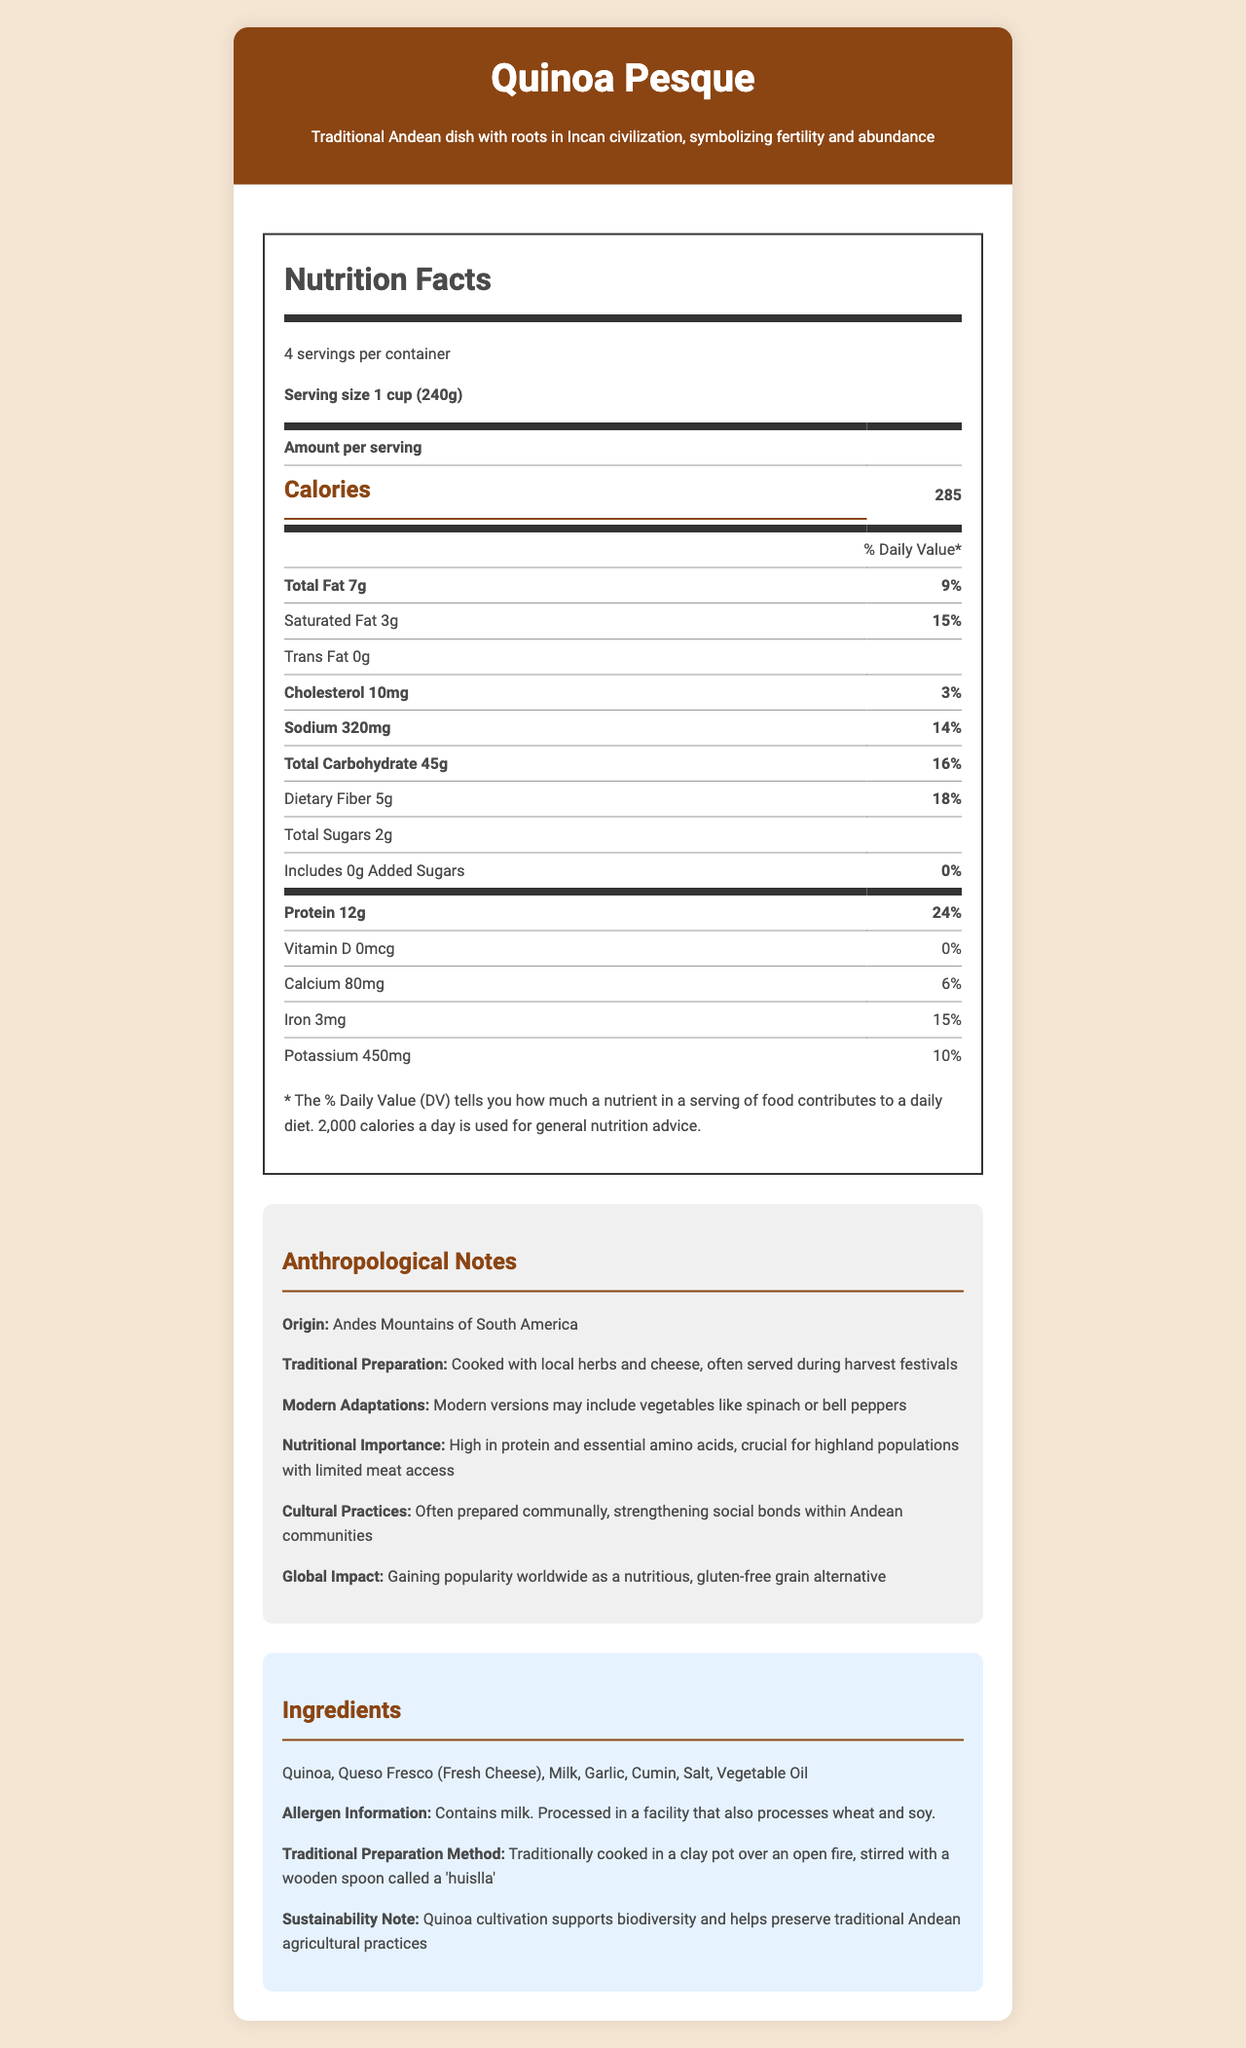How many servings are in one container of Quinoa Pesque? The document states that there are 4 servings per container for Quinoa Pesque.
Answer: 4 servings What is the serving size of Quinoa Pesque? The serving size of Quinoa Pesque is listed as 1 cup (240g) in the document.
Answer: 1 cup (240g) How many calories are there per serving? The number of calories per serving of Quinoa Pesque is 285, as mentioned in the document.
Answer: 285 calories What percentage of daily value for protein does one serving of Quinoa Pesque provide? One serving of Quinoa Pesque provides 24% of the daily value for protein.
Answer: 24% What is the origin of Quinoa Pesque? The document states that the origin of Quinoa Pesque is the Andes Mountains of South America.
Answer: Andes Mountains of South America How much saturated fat is in one serving? One serving of Quinoa Pesque contains 3 grams of saturated fat, as mentioned in the document.
Answer: 3g Does Quinoa Pesque contain any added sugars? The document states that Quinoa Pesque contains 0 grams of added sugars.
Answer: No What is the traditional preparation method of Quinoa Pesque? The traditional preparation method listed in the document describes cooking in a clay pot over an open fire, stirred with a wooden spoon called a 'huislla'.
Answer: Cooked in a clay pot over an open fire, stirred with a wooden spoon called a 'huislla' Which of the following ingredients are NOT included in Quinoa Pesque? A. Quinoa B. Queso Fresco (Fresh Cheese) C. Chicken D. Garlic Chicken is not listed among the ingredients in the document, whereas Quinoa, Queso Fresco, and Garlic are included.
Answer: C. Chicken What makes Quinoa Pesque culturally significant? A. It is a staple food worldwide B. It has roots in Incan civilization and symbolizes fertility and abundance C. It was created in the 20th century D. It is a common fast food item The document states that Quinoa Pesque's cultural significance is due to its roots in Incan civilization and its symbolism of fertility and abundance.
Answer: B. It has roots in Incan civilization and symbolizes fertility and abundance Is Quinoa Pesque considered a sustainable food option? The document mentions that quinoa cultivation supports biodiversity and helps preserve traditional Andean agricultural practices, making it a sustainable food option.
Answer: Yes Summarize the main cultural and nutritional highlights of Quinoa Pesque. The document extensively covers the cultural significance of Quinoa Pesque, its traditional and modern preparations, nutritional importance, cultural practices, and its global impact, summarizing how it is both culturally significant and nutritionally beneficial.
Answer: Quinoa Pesque is a traditional Andean dish with roots in the Incan civilization, symbolizing fertility and abundance. It has a high protein content, essential amino acids, and is low in added sugars. Traditionally prepared in a communal setting, it strengthens social bonds within Andean communities. Modern adaptations include adding vegetables like spinach or bell peppers. The dish supports sustainability and has gained popularity worldwide as a nutritious, gluten-free grain alternative. What are the allergens noted in Quinoa Pesque? The document notes that Quinoa Pesque contains milk and is processed in a facility that also processes wheat and soy.
Answer: Milk What are the health benefits of consuming Quinoa Pesque for highland populations? The document states that Quinoa Pesque is high in protein and essential amino acids, which are crucial for highland populations with limited access to meat.
Answer: High in protein and essential amino acids, crucial for populations with limited meat access What percentage of the daily value of calcium is provided per serving of Quinoa Pesque? The document states that one serving of Quinoa Pesque provides 6% of the daily value of calcium.
Answer: 6% What vitamin is not present in Quinoa Pesque? The document states that Quinoa Pesque contains 0 micrograms and 0% daily value of Vitamin D.
Answer: Vitamin D How is Quinoa Pesque traditionally prepared during harvest festivals? The document indicates that Quinoa Pesque is traditionally prepared with local herbs and cheese during harvest festivals.
Answer: Cooked with local herbs and cheese What are some modern adaptations of Quinoa Pesque? The document notes that modern versions of Quinoa Pesque may include vegetables like spinach or bell peppers.
Answer: Including vegetables like spinach or bell peppers Who first cultivated Quinoa Pesque, and what cultural practice is associated with its preparation? The document states that Quinoa Pesque has roots in the Incan civilization and is often prepared communally, which strengthens social bonds within Andean communities.
Answer: The Incan civilization first cultivated it, and it is often prepared communally, strengthening social bonds within Andean communities What is the impact of Quinoa Pesque on global nutrition trends? The document mentions that Quinoa Pesque is gaining popularity globally as a nutritious, gluten-free grain alternative.
Answer: Gaining popularity worldwide as a nutritious, gluten-free grain alternative How many calories does a container of Quinoa Pesque contain? The document does not provide the total number of calories for the entire container of Quinoa Pesque, just the calories per serving.
Answer: Cannot be determined 